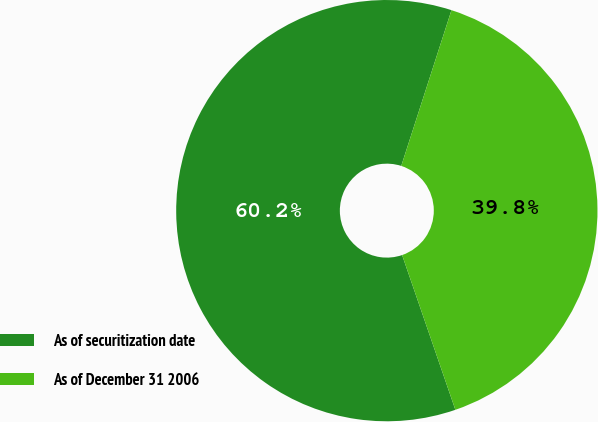Convert chart. <chart><loc_0><loc_0><loc_500><loc_500><pie_chart><fcel>As of securitization date<fcel>As of December 31 2006<nl><fcel>60.24%<fcel>39.76%<nl></chart> 